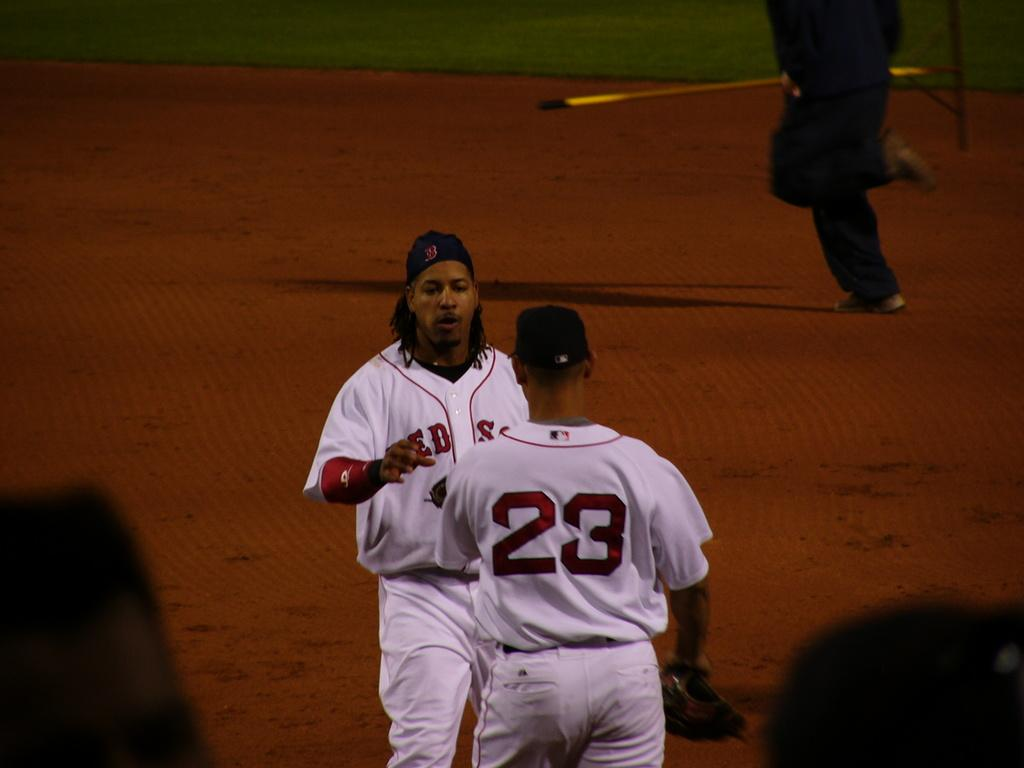<image>
Render a clear and concise summary of the photo. Two Red Sox players talk to each other in the infield. 